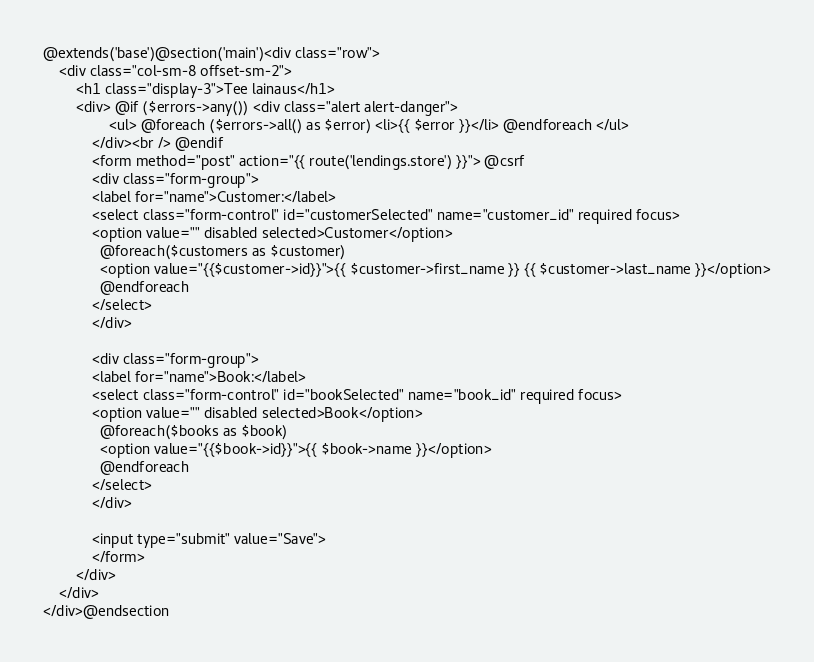<code> <loc_0><loc_0><loc_500><loc_500><_PHP_>@extends('base')@section('main')<div class="row">
    <div class="col-sm-8 offset-sm-2">
        <h1 class="display-3">Tee lainaus</h1>
        <div> @if ($errors->any()) <div class="alert alert-danger">
                <ul> @foreach ($errors->all() as $error) <li>{{ $error }}</li> @endforeach </ul>
            </div><br /> @endif 
            <form method="post" action="{{ route('lendings.store') }}"> @csrf 
            <div class="form-group"> 
            <label for="name">Customer:</label> 
            <select class="form-control" id="customerSelected" name="customer_id" required focus>
            <option value="" disabled selected>Customer</option>        
              @foreach($customers as $customer)
              <option value="{{$customer->id}}">{{ $customer->first_name }} {{ $customer->last_name }}</option>
              @endforeach
            </select>
            </div>

            <div class="form-group"> 
            <label for="name">Book:</label> 
            <select class="form-control" id="bookSelected" name="book_id" required focus>
            <option value="" disabled selected>Book</option>        
              @foreach($books as $book)
              <option value="{{$book->id}}">{{ $book->name }}</option>
              @endforeach
            </select>
            </div>
           
            <input type="submit" value="Save">
            </form>
        </div>
    </div>
</div>@endsection</code> 